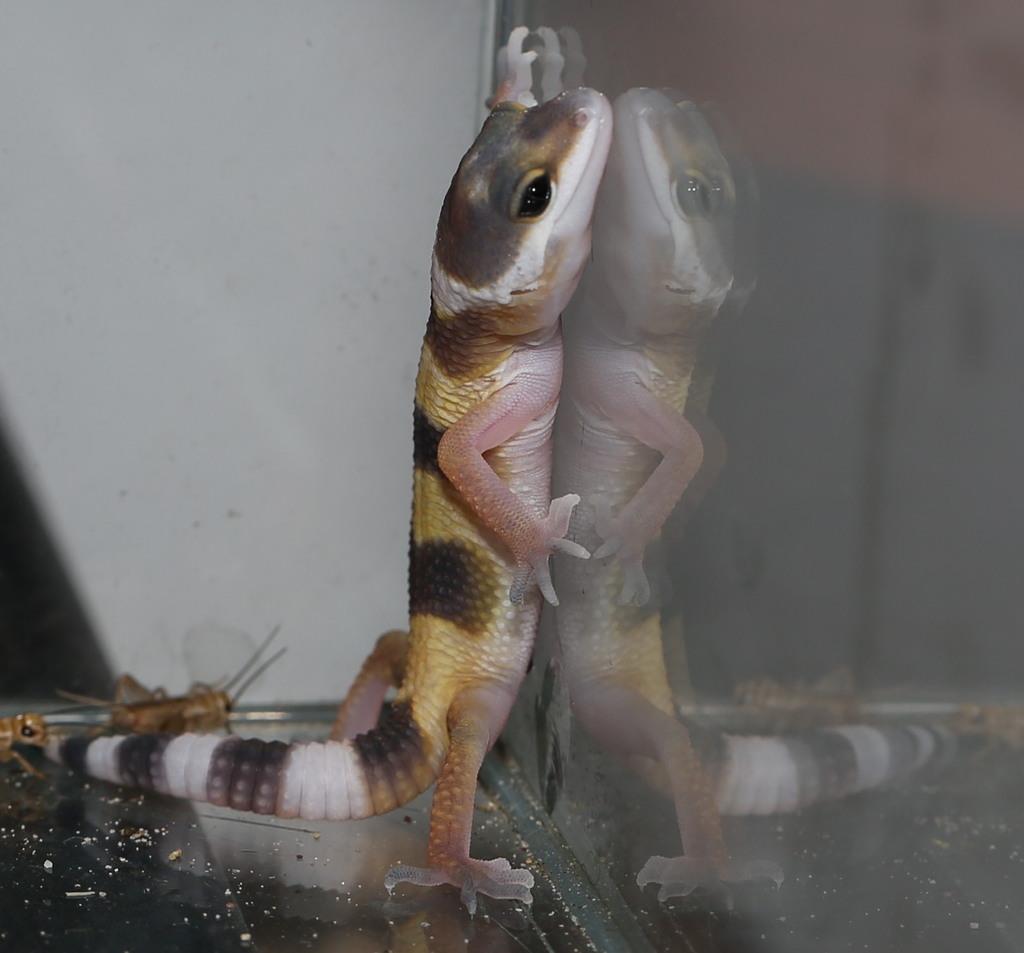Describe this image in one or two sentences. On the right side, there is a lizard on a glass surface, on which there is a dust. In the background, there is a white wall. 